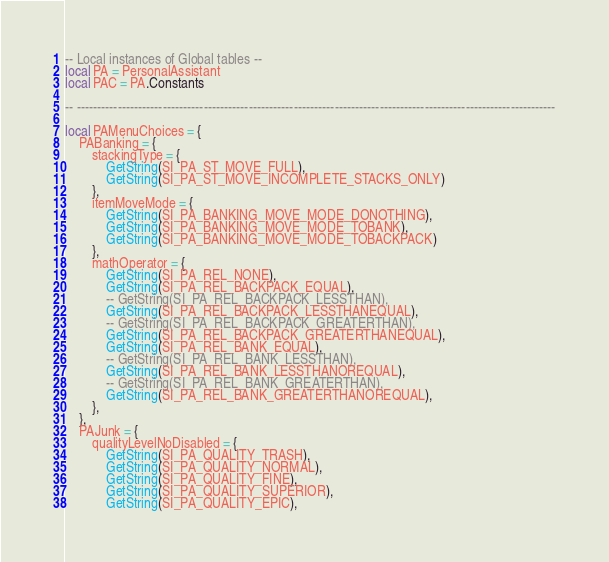Convert code to text. <code><loc_0><loc_0><loc_500><loc_500><_Lua_>-- Local instances of Global tables --
local PA = PersonalAssistant
local PAC = PA.Constants

-- ---------------------------------------------------------------------------------------------------------------------

local PAMenuChoices = {
    PABanking = {
        stackingType = {
            GetString(SI_PA_ST_MOVE_FULL),
            GetString(SI_PA_ST_MOVE_INCOMPLETE_STACKS_ONLY)
        },
        itemMoveMode = {
            GetString(SI_PA_BANKING_MOVE_MODE_DONOTHING),
            GetString(SI_PA_BANKING_MOVE_MODE_TOBANK),
            GetString(SI_PA_BANKING_MOVE_MODE_TOBACKPACK)
        },
        mathOperator = {
            GetString(SI_PA_REL_NONE),
            GetString(SI_PA_REL_BACKPACK_EQUAL),
            -- GetString(SI_PA_REL_BACKPACK_LESSTHAN),
            GetString(SI_PA_REL_BACKPACK_LESSTHANEQUAL),
            -- GetString(SI_PA_REL_BACKPACK_GREATERTHAN),
            GetString(SI_PA_REL_BACKPACK_GREATERTHANEQUAL),
            GetString(SI_PA_REL_BANK_EQUAL),
            -- GetString(SI_PA_REL_BANK_LESSTHAN),
            GetString(SI_PA_REL_BANK_LESSTHANOREQUAL),
            -- GetString(SI_PA_REL_BANK_GREATERTHAN),
            GetString(SI_PA_REL_BANK_GREATERTHANOREQUAL),
        },
    },
    PAJunk = {
        qualityLevelNoDisabled = {
            GetString(SI_PA_QUALITY_TRASH),
            GetString(SI_PA_QUALITY_NORMAL),
            GetString(SI_PA_QUALITY_FINE),
            GetString(SI_PA_QUALITY_SUPERIOR),
            GetString(SI_PA_QUALITY_EPIC),</code> 